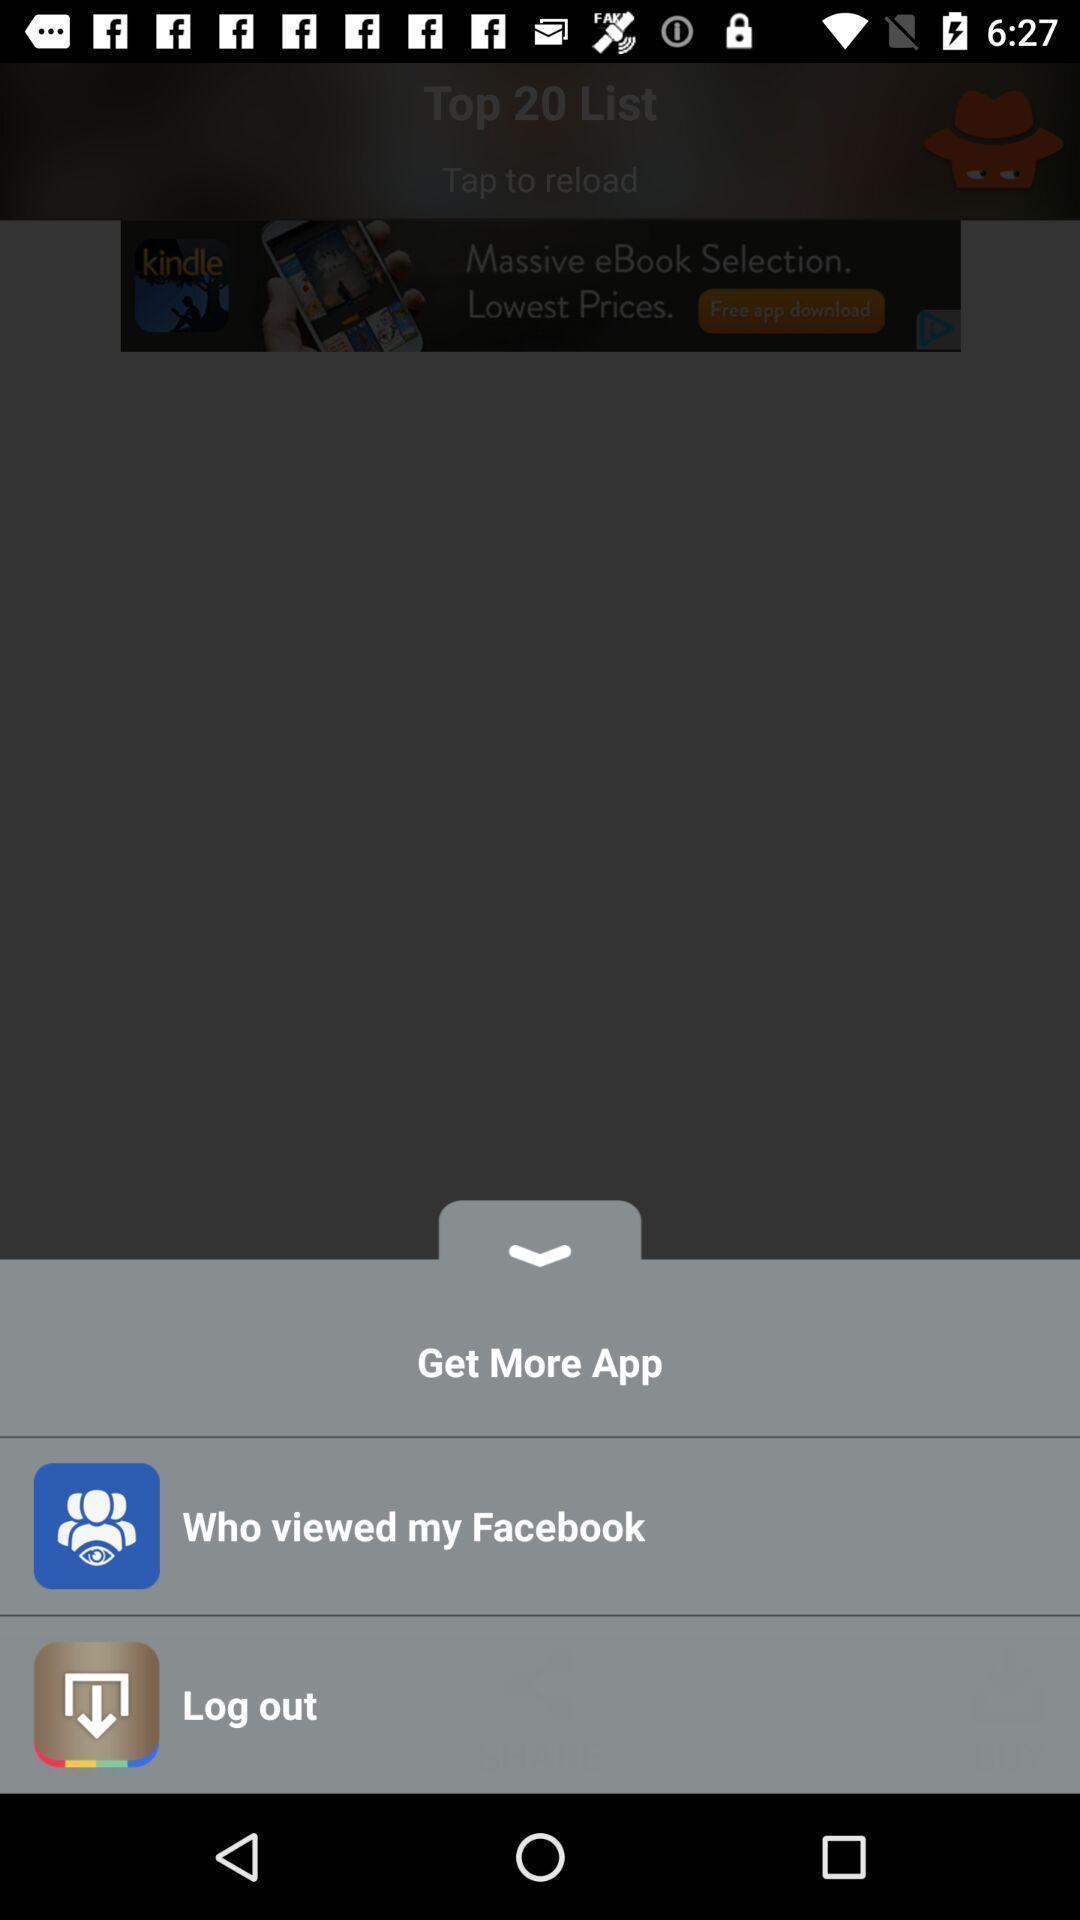Describe this image in words. Push up message with options. 